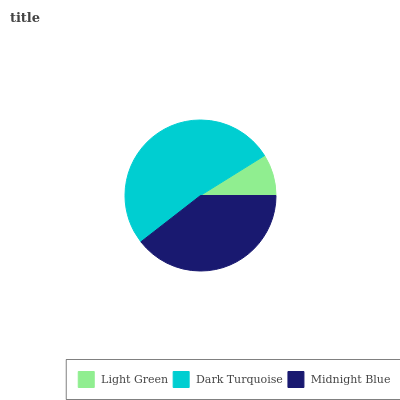Is Light Green the minimum?
Answer yes or no. Yes. Is Dark Turquoise the maximum?
Answer yes or no. Yes. Is Midnight Blue the minimum?
Answer yes or no. No. Is Midnight Blue the maximum?
Answer yes or no. No. Is Dark Turquoise greater than Midnight Blue?
Answer yes or no. Yes. Is Midnight Blue less than Dark Turquoise?
Answer yes or no. Yes. Is Midnight Blue greater than Dark Turquoise?
Answer yes or no. No. Is Dark Turquoise less than Midnight Blue?
Answer yes or no. No. Is Midnight Blue the high median?
Answer yes or no. Yes. Is Midnight Blue the low median?
Answer yes or no. Yes. Is Light Green the high median?
Answer yes or no. No. Is Dark Turquoise the low median?
Answer yes or no. No. 